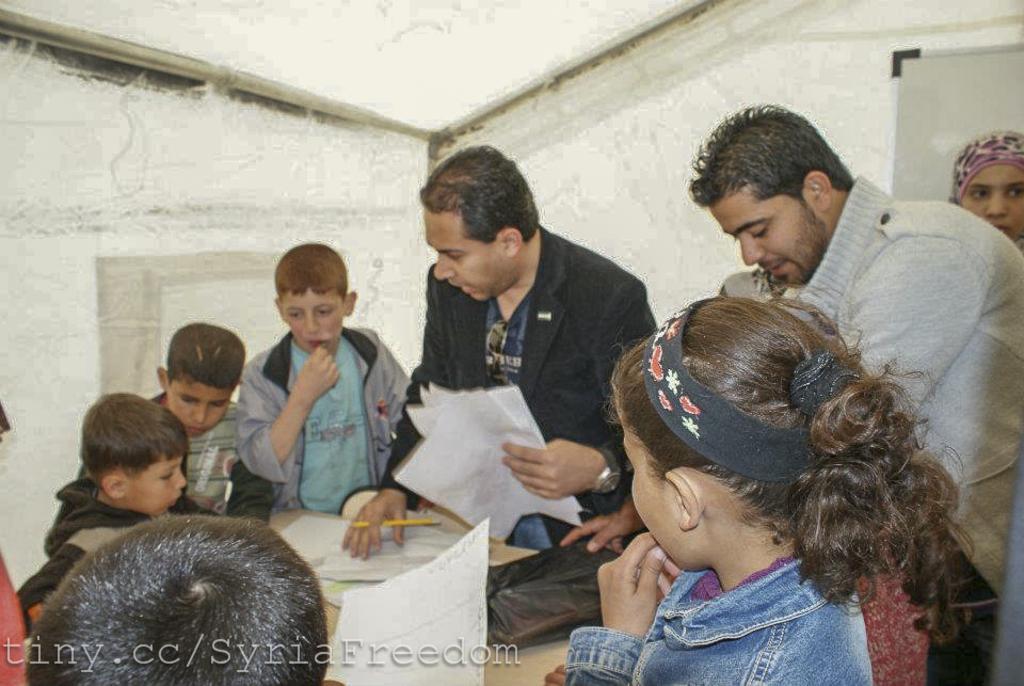Can you describe this image briefly? In this image we can see these persons here and children here and this person is holding papers and pen and we can see a few more papers on the table. In the background, we can see the wall and the board. Here we can see the watermark on the bottom left side of the image. 